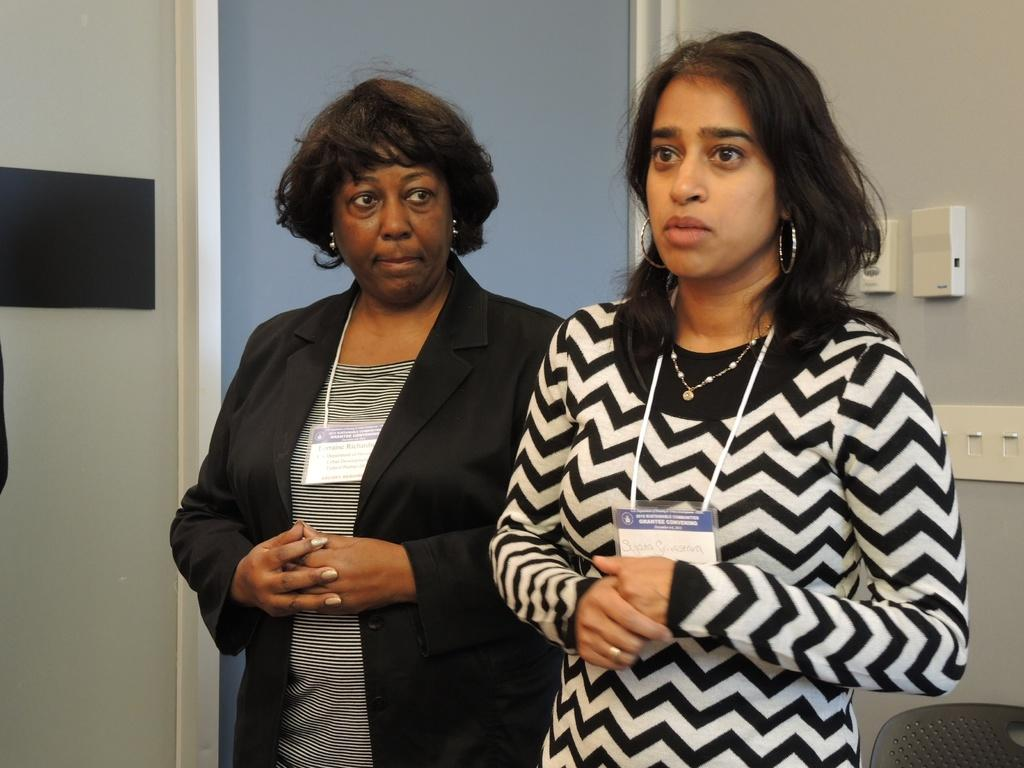How many people are in the image? There are two women in the picture. Where are the women located in the image? The women are standing in the middle of the picture. What can be seen in the background of the image? There is a wall in the background of the picture. How many snails can be seen crawling on the wall in the image? There are no snails visible in the image; only the two women and the wall are present. What type of fly is buzzing around the women in the image? There are no flies present in the image; the focus is on the two women and the wall. 